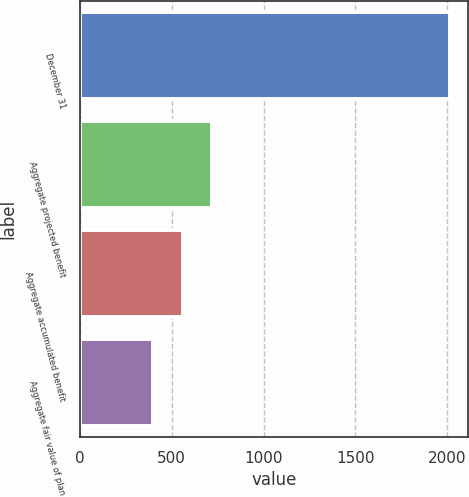Convert chart. <chart><loc_0><loc_0><loc_500><loc_500><bar_chart><fcel>December 31<fcel>Aggregate projected benefit<fcel>Aggregate accumulated benefit<fcel>Aggregate fair value of plan<nl><fcel>2014<fcel>721.32<fcel>559.5<fcel>395.8<nl></chart> 